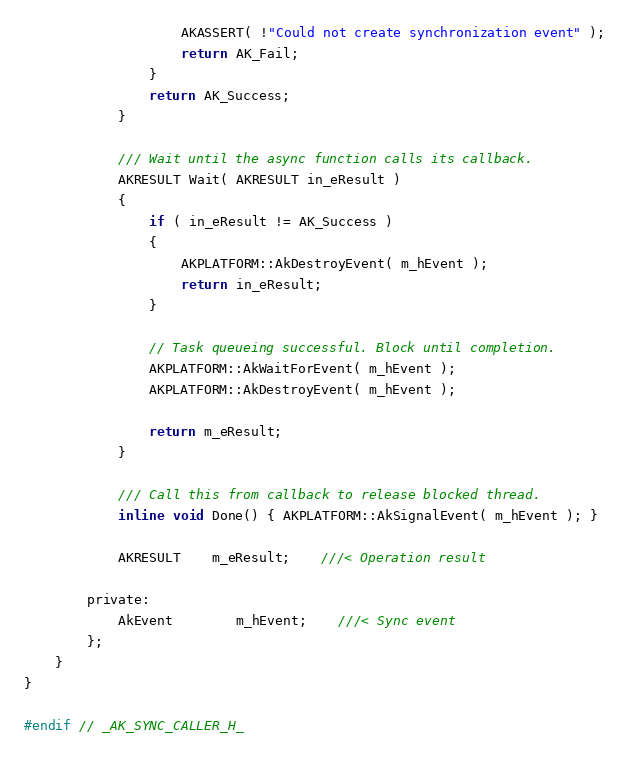<code> <loc_0><loc_0><loc_500><loc_500><_C_>					AKASSERT( !"Could not create synchronization event" );
					return AK_Fail;
				}
				return AK_Success;
			}

			/// Wait until the async function calls its callback.
			AKRESULT Wait( AKRESULT in_eResult )
			{
				if ( in_eResult != AK_Success )
				{
					AKPLATFORM::AkDestroyEvent( m_hEvent );
					return in_eResult;
				}

				// Task queueing successful. Block until completion.
				AKPLATFORM::AkWaitForEvent( m_hEvent );
				AKPLATFORM::AkDestroyEvent( m_hEvent );

				return m_eResult;
			}

			/// Call this from callback to release blocked thread.
			inline void Done() { AKPLATFORM::AkSignalEvent( m_hEvent ); }

			AKRESULT	m_eResult;	///< Operation result

		private:
			AkEvent		m_hEvent;	///< Sync event
		};
	}
}

#endif // _AK_SYNC_CALLER_H_
</code> 